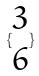<formula> <loc_0><loc_0><loc_500><loc_500>\{ \begin{matrix} 3 \\ 6 \end{matrix} \}</formula> 